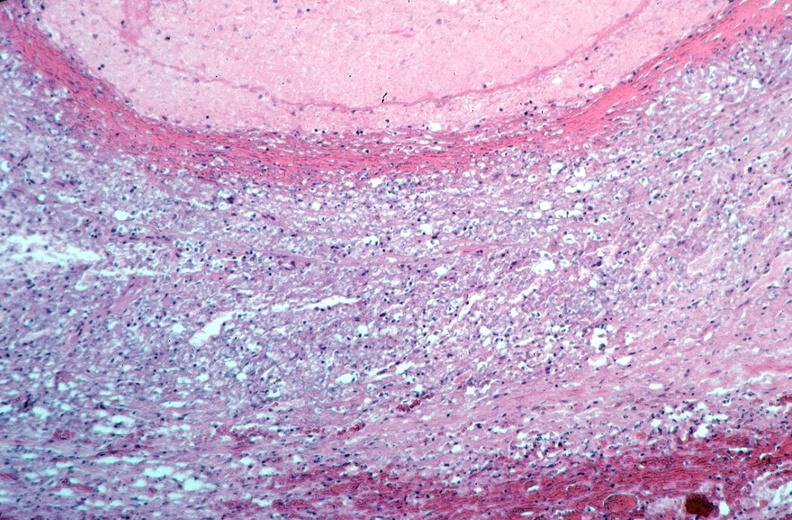what does this image show?
Answer the question using a single word or phrase. Vasculitis 